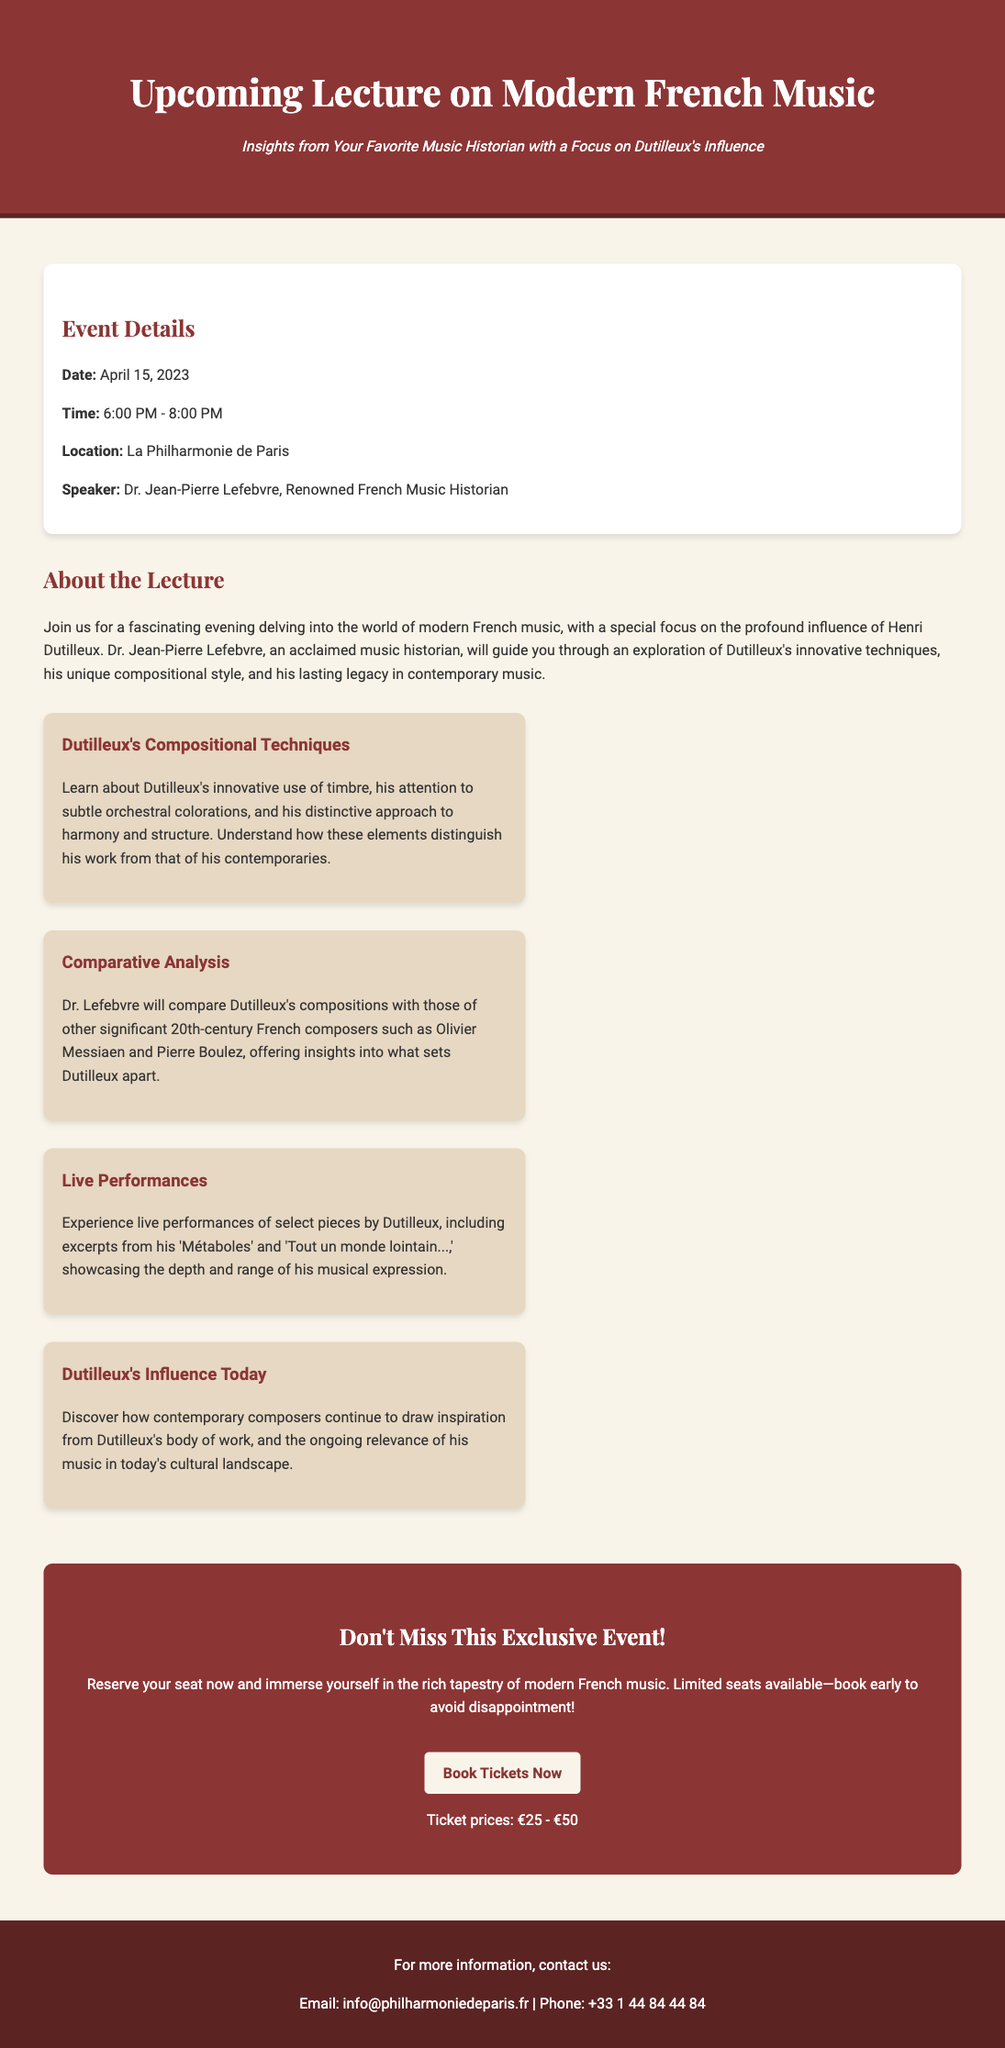What is the date of the lecture? The document specifies the date of the lecture as April 15, 2023.
Answer: April 15, 2023 Who is the speaker for the event? The advertisement lists Dr. Jean-Pierre Lefebvre as the speaker.
Answer: Dr. Jean-Pierre Lefebvre What time does the lecture start? The document indicates that the lecture starts at 6:00 PM.
Answer: 6:00 PM What is the location of the event? The location mentioned in the document is La Philharmonie de Paris.
Answer: La Philharmonie de Paris What is the range of ticket prices? The document states the ticket prices range from €25 to €50.
Answer: €25 - €50 What is a focus of Dr. Lefebvre's lecture? The lecture focuses on the influence of Henri Dutilleux in modern French music.
Answer: Henri Dutilleux What type of performances will be included? The document mentions live performances of select pieces by Dutilleux.
Answer: Live performances What is highlighted about Dutilleux's compositional techniques? The document states that his innovative use of timbre and orchestral colorations is highlighted.
Answer: Innovative use of timbre How can attendees reserve their seats? Attendees can reserve their seats by clicking on the "Book Tickets Now" button.
Answer: Book Tickets Now What contact information is provided for further inquiries? The document includes an email and phone number for inquiries: info@philharmoniedeparis.fr
Answer: info@philharmoniedeparis.fr 